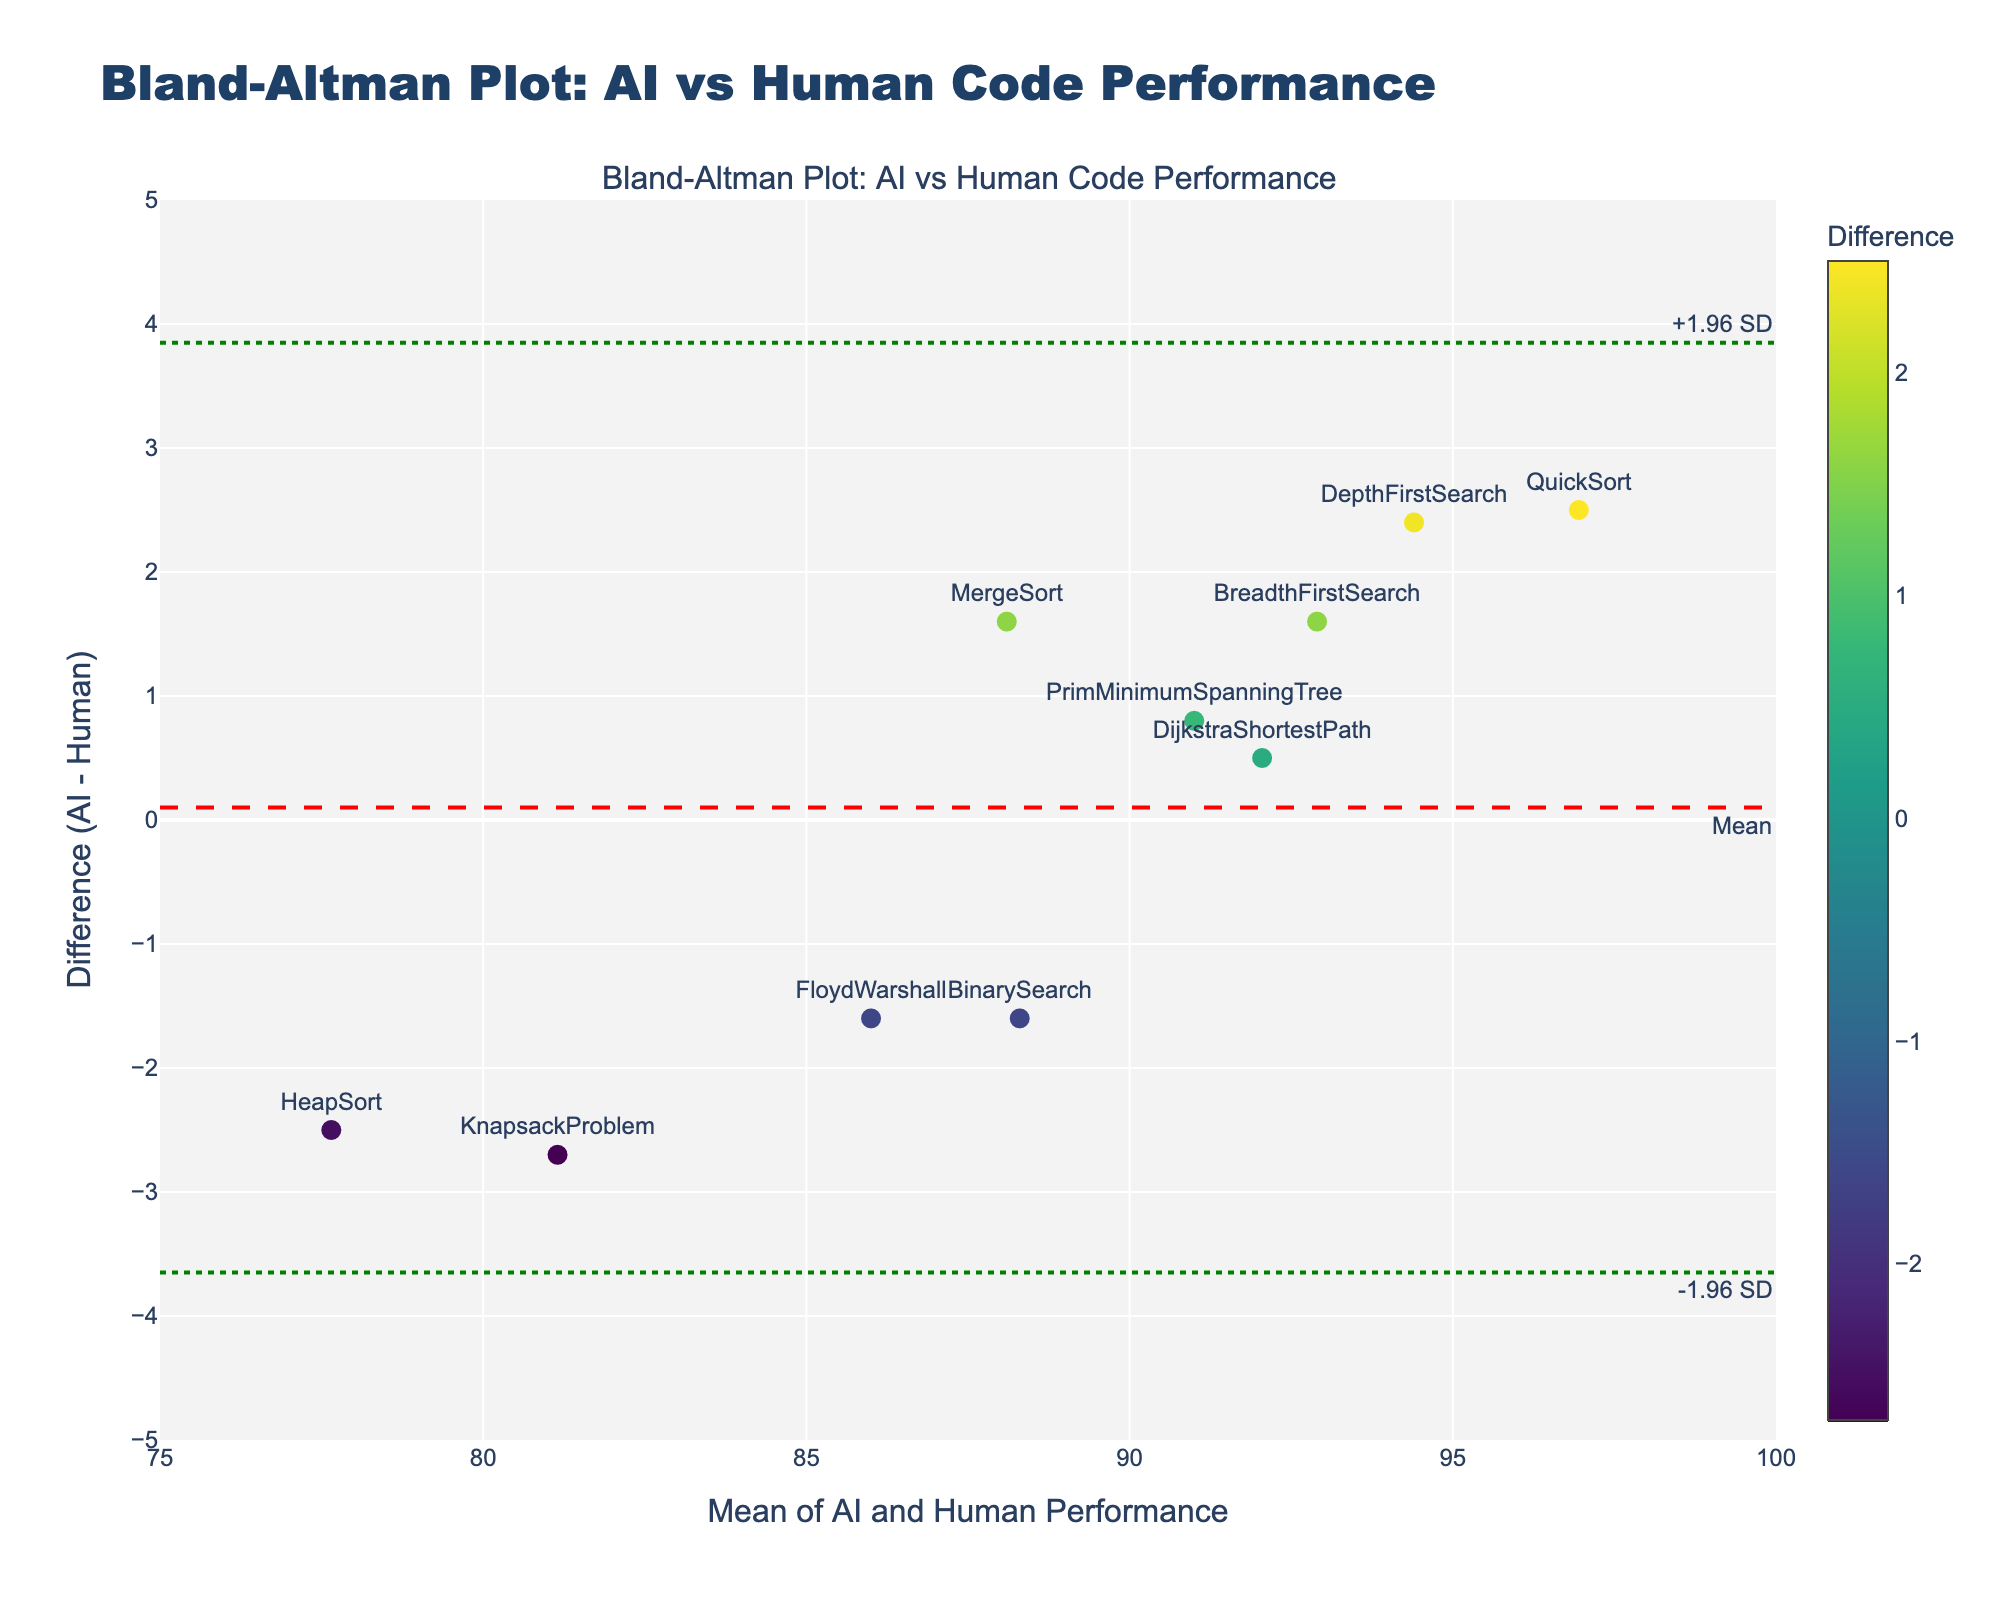What does the title of the plot indicate? The title of the plot is "Bland-Altman Plot: AI vs Human Code Performance". This indicates that the plot is used to compare the performance metrics of AI-generated code and human-written code through a Bland-Altman analysis.
Answer: Bland-Altman Plot: AI vs Human Code Performance What are the y-axis units of the Bland-Altman plot? The y-axis of the Bland-Altman plot represents the difference between the AI-generated performance and the human-written performance metrics.
Answer: Difference (AI - Human) What is the mean difference between AI-generated and human-written performance metrics? The plot shows a red dashed line representing the mean difference. The annotation on this line indicates it is located around 0.71 on the y-axis.
Answer: 0.71 What is the range of the limits of agreement? The limits of agreement are shown by the green dotted lines on the plot. These lines are annotated with "-1.96 SD" and "+1.96 SD", positioned around -1.77 and 3.19 on the y-axis, respectively.
Answer: -1.77 to 3.19 What does the mean line in red represent in the plot? The red dashed line represents the mean difference between AI-generated and human-written code performance metrics. This line helps to visualize the central tendency of the differences.
Answer: Mean difference How does the performance of QuickSort compare to the mean difference? The QuickSort algorithm's difference is represented by a point annotated "QuickSort" and positioned above the mean difference line, indicating that the AI-generated performance for QuickSort is higher than the human-written performance.
Answer: Higher than mean Which algorithm shows the largest positive difference in performance? The algorithm with the largest positive difference is QuickSort, as it is the highest data point on the y-axis of Difference (AI - Human).
Answer: QuickSort Are there any algorithms where the human-written performance is better than the AI-generated performance? Name one. Yes, there are points above the mean difference line in the negative range. For example, BinarySearch has a negative difference, indicating human-written performance was better.
Answer: BinarySearch What is the average of the means of AI and human performances for the DepthFirstSearch algorithm? For DepthFirstSearch, the mean of AI and human performances can be calculated by averaging its coordinates on the x-axis. The x-value for DepthFirstSearch is around 94.4.
Answer: 94.4 